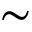Convert formula to latex. <formula><loc_0><loc_0><loc_500><loc_500>\sim</formula> 